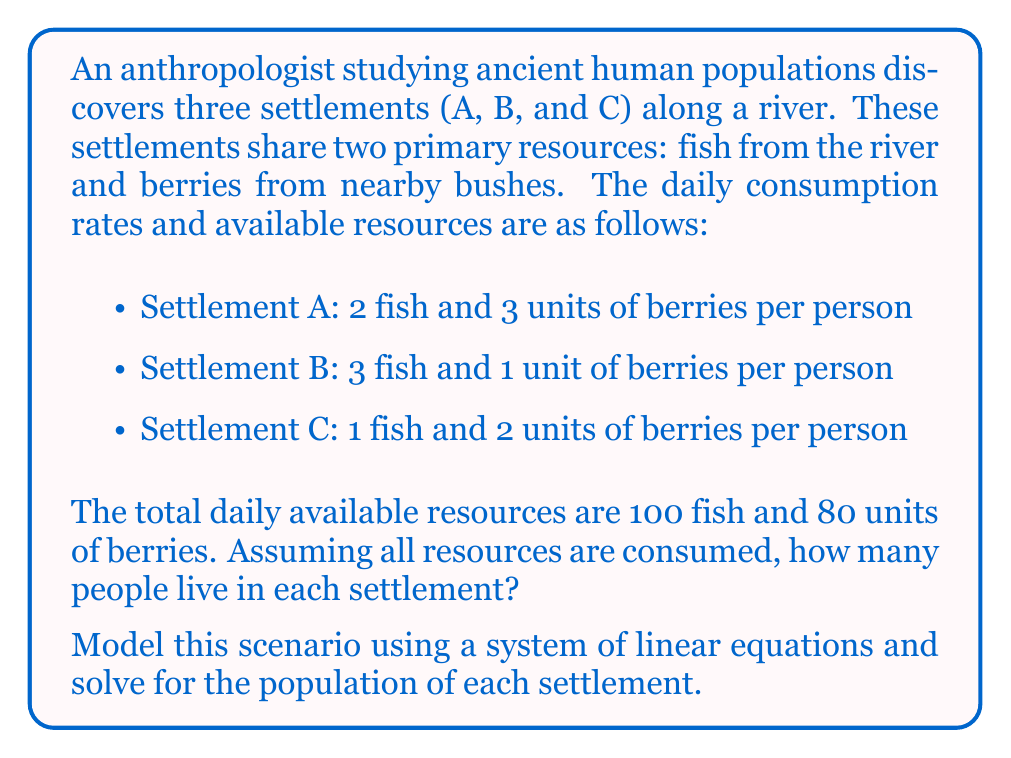Provide a solution to this math problem. Let's approach this step-by-step:

1) Define variables:
   Let $x$, $y$, and $z$ represent the number of people in settlements A, B, and C respectively.

2) Set up the system of linear equations:
   For fish: $2x + 3y + z = 100$
   For berries: $3x + y + 2z = 80$

3) We now have a system of two equations with three unknowns:
   $$\begin{cases}
   2x + 3y + z = 100 \\
   3x + y + 2z = 80
   \end{cases}$$

4) To solve this, we need a third equation. In anthropological studies, it's common to assume population balance among settlements. Let's assume the population of C is the average of A and B:
   $z = \frac{x + y}{2}$

5) Now we have a solvable system:
   $$\begin{cases}
   2x + 3y + z = 100 \\
   3x + y + 2z = 80 \\
   2z = x + y
   \end{cases}$$

6) Substitute the third equation into the first two:
   $$\begin{cases}
   2x + 3y + \frac{x + y}{2} = 100 \\
   3x + y + (x + y) = 80
   \end{cases}$$

7) Simplify:
   $$\begin{cases}
   5x + 7y = 200 \\
   4x + 2y = 80
   \end{cases}$$

8) Multiply the second equation by 2:
   $$\begin{cases}
   5x + 7y = 200 \\
   8x + 4y = 160
   \end{cases}$$

9) Subtract the first equation from the second:
   $3x - 3y = -40$
   $x - y = -\frac{40}{3}$

10) Substitute this into the first equation of step 7:
    $5(\frac{40}{3} + y) + 7y = 200$
    $\frac{200}{3} + 5y + 7y = 200$
    $12y = 400 - \frac{200}{3} = \frac{1000}{3}$
    $y = \frac{250}{9} \approx 27.78$

11) Round to the nearest whole number: $y = 28$

12) Find $x$ using the equation from step 9:
    $x = 28 - \frac{40}{3} \approx 14.67$
    Round to the nearest whole number: $x = 15$

13) Find $z$ using the equation from step 4:
    $z = \frac{15 + 28}{2} = 21.5$
    Round to the nearest whole number: $z = 22$

Therefore, Settlement A has 15 people, B has 28 people, and C has 22 people.
Answer: A: 15, B: 28, C: 22 